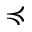<formula> <loc_0><loc_0><loc_500><loc_500>\prec c u r l y e q</formula> 